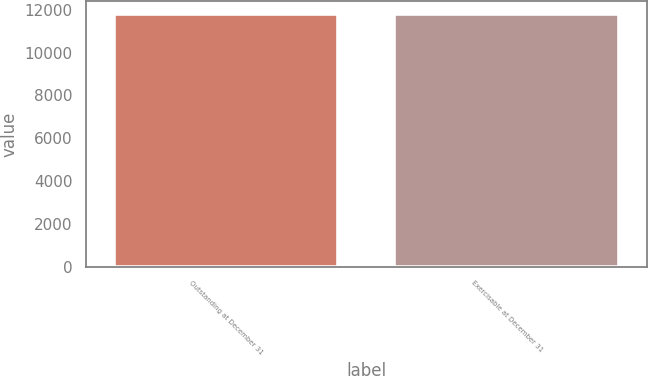Convert chart to OTSL. <chart><loc_0><loc_0><loc_500><loc_500><bar_chart><fcel>Outstanding at December 31<fcel>Exercisable at December 31<nl><fcel>11809<fcel>11809.1<nl></chart> 